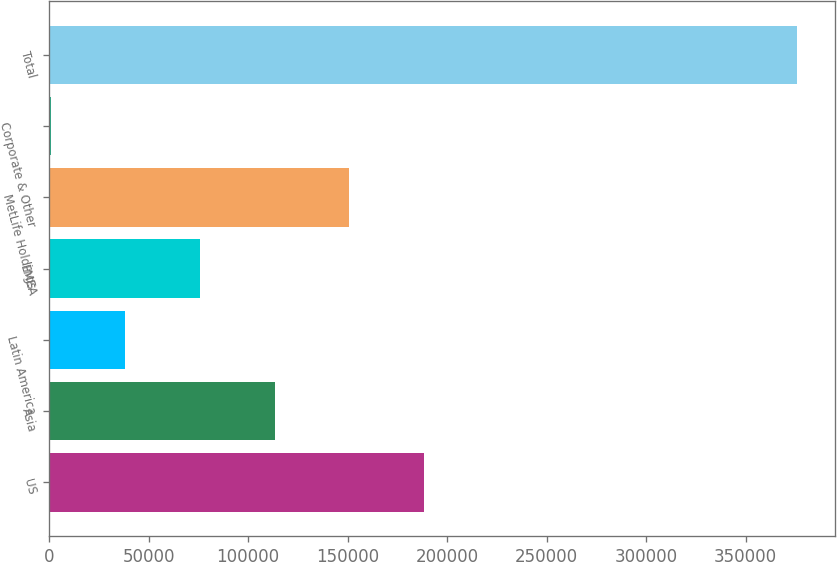Convert chart to OTSL. <chart><loc_0><loc_0><loc_500><loc_500><bar_chart><fcel>US<fcel>Asia<fcel>Latin America<fcel>EMEA<fcel>MetLife Holdings<fcel>Corporate & Other<fcel>Total<nl><fcel>188418<fcel>113382<fcel>38346.8<fcel>75864.6<fcel>150900<fcel>829<fcel>376007<nl></chart> 